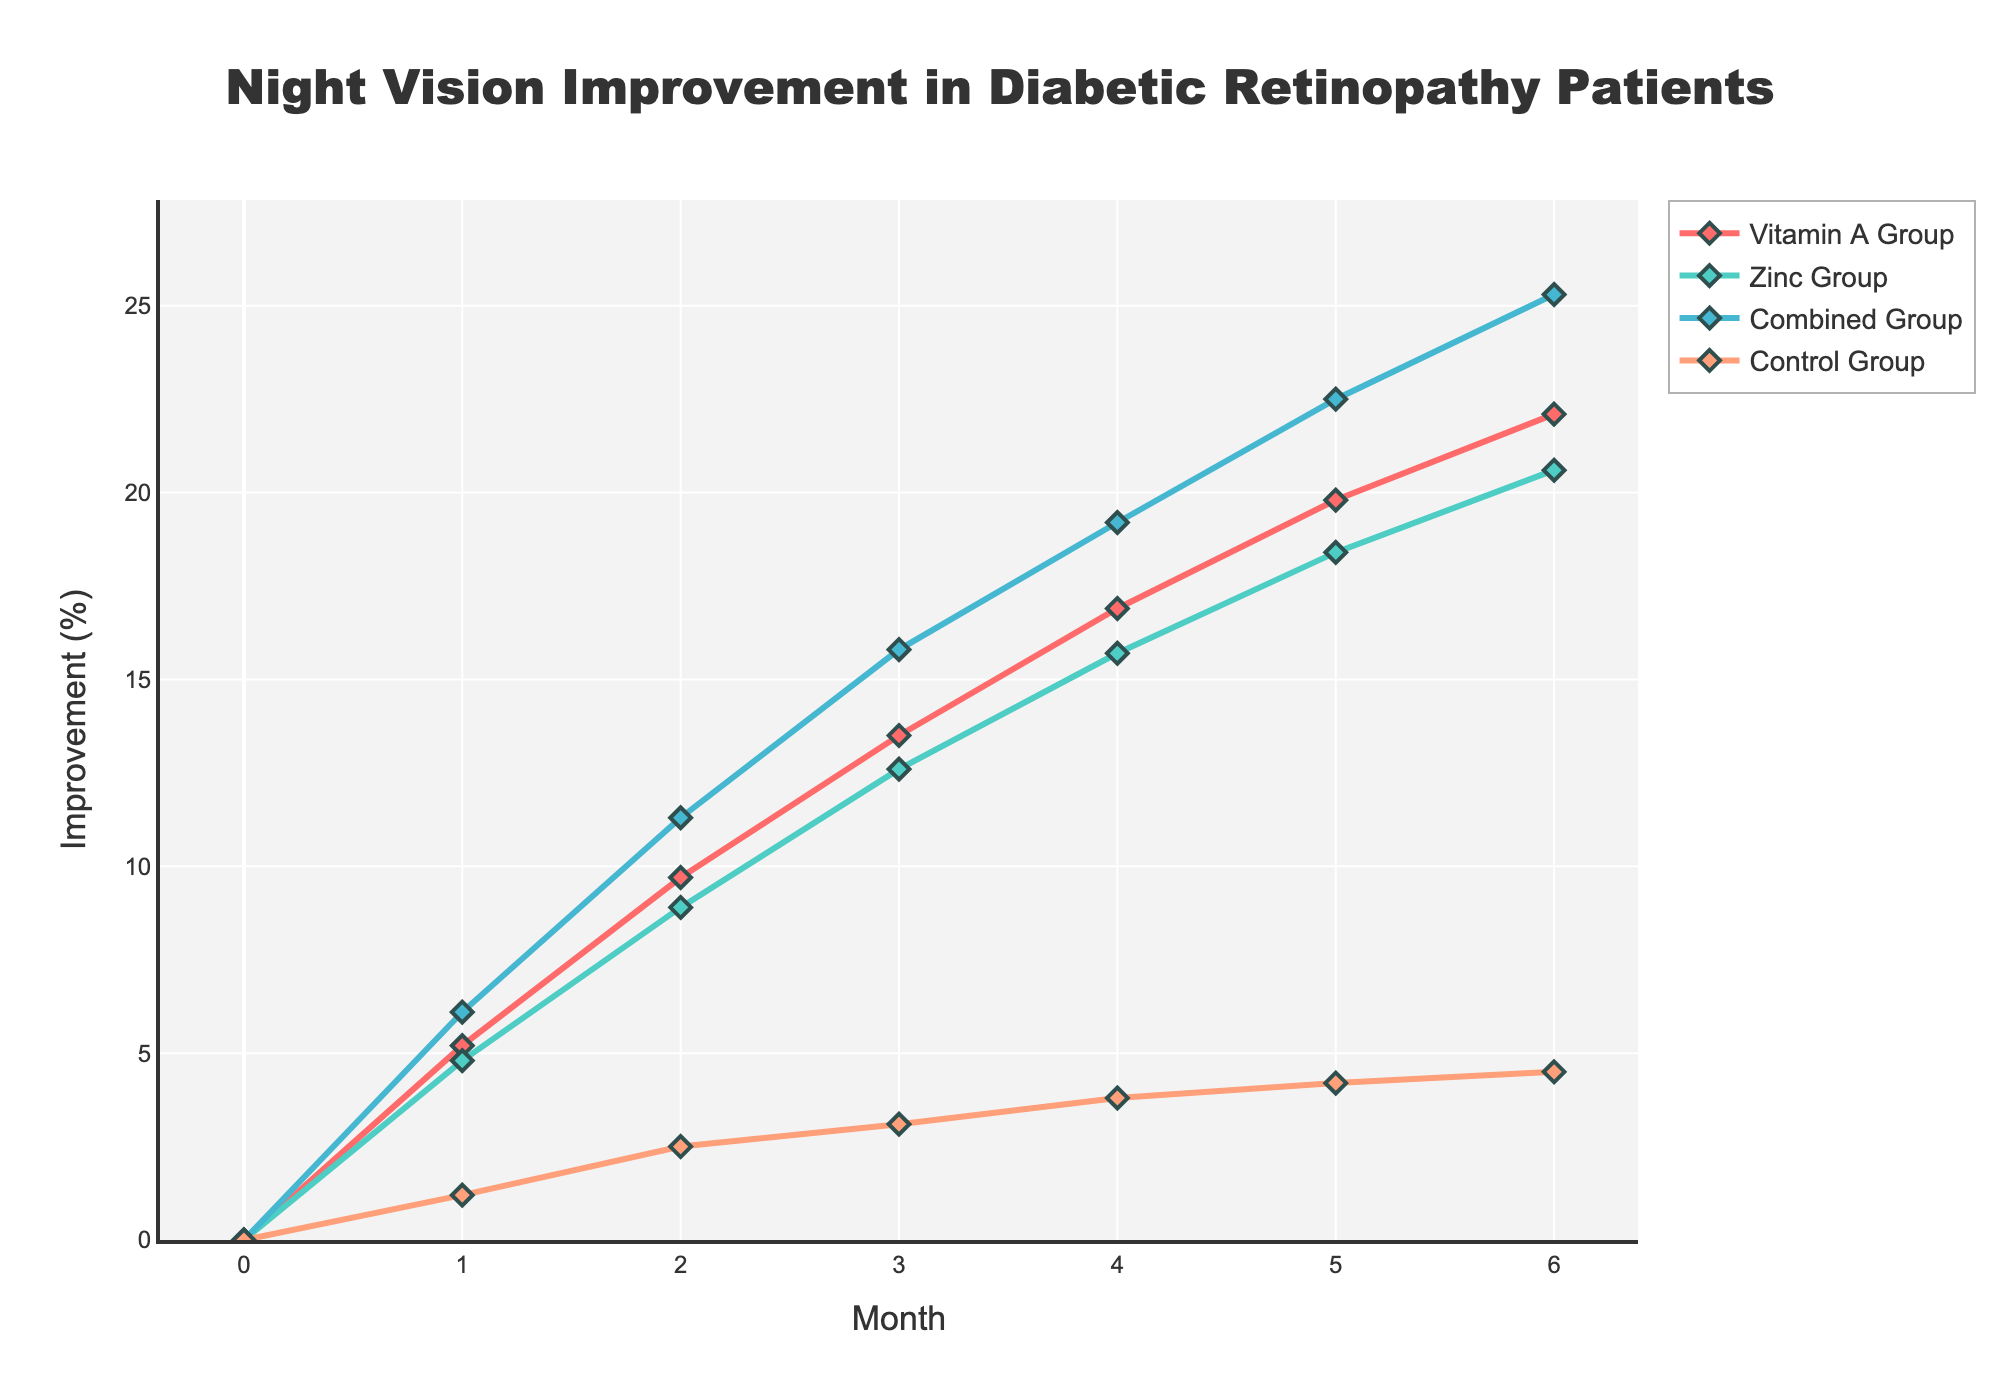what trend do you observe in the Combined Group over the 6-month period? The trend in the Combined Group shows a steady and continuous increase in night vision improvement over the 6-month period, from 0% at month 0 to 25.3% at month 6.
Answer: It shows a steady increase Which group had the highest improvement in night vision at the end of month 3? At the end of month 3, we look at the y-axis value for each group at the respective data points. The Combined Group has the highest improvement with 15.8%.
Answer: Combined Group How does the Control Group's improvement compare to the Zinc Group at month 2? At month 2, comparing the y-axis positions of both groups, the Control Group is around 2.5% while the Zinc Group is around 8.9%. The Zinc Group’s improvement is significantly higher.
Answer: Zinc Group is higher What is the average improvement for the Vitamin A Group over the 6-month period? Summing the improvements for the Vitamin A Group (0 + 5.2 + 9.7 + 13.5 + 16.9 + 19.8 + 22.1 = 87.2) and then dividing by the number of months (7), the average improvement is (87.2 / 7) ≈ 12.46%.
Answer: 12.46% How much more did the Combined Group improve compared to the Control Group at the end of the study? At month 6, the Combined Group improved by 25.3%, and the Control Group improved by 4.5%. The difference in improvement is 25.3% - 4.5% = 20.8%.
Answer: 20.8% Which group showed the smallest improvement over the 6-month period? By observing the trend lines and final improvement values at month 6, the Control Group showed the smallest improvement with 4.5%.
Answer: Control Group At which month does the Zinc Group's improvement surpass the 10% mark? In the Zinc Group's line, we see surpassing the 10% value between months 2 and 3. However, it is not exact and occurs slightly after month 2.
Answer: Shortly after month 2 If we combine the improvements of the Vitamin A and Zinc Groups at month 4, what would the total be? At month 4, the Vitamin A Group improved by 16.9% and the Zinc Group by 15.7%. Adding these values gives a total of 16.9% + 15.7% = 32.6%.
Answer: 32.6% Which group had the fastest initial improvement in the first month? In the first month, comparing the y-axis values of all groups: the Combined Group improved by 6.1%, which is the highest among all groups.
Answer: Combined Group What color represents the Zinc Group in the figure? By noting the color assigned to each group, the Zinc Group is represented by the green line.
Answer: Green 